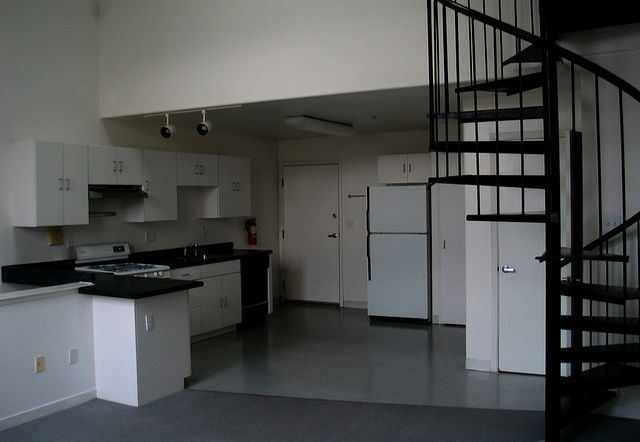<image>What kind of lighting is shown? It is ambiguous what kind of lighting is shown. It can be track, bulb, fluorescent, natural, or artificial. What kind of lighting is shown? It is ambiguous what kind of lighting is shown. It can be track, bulb, none, fluorescent or natural. 